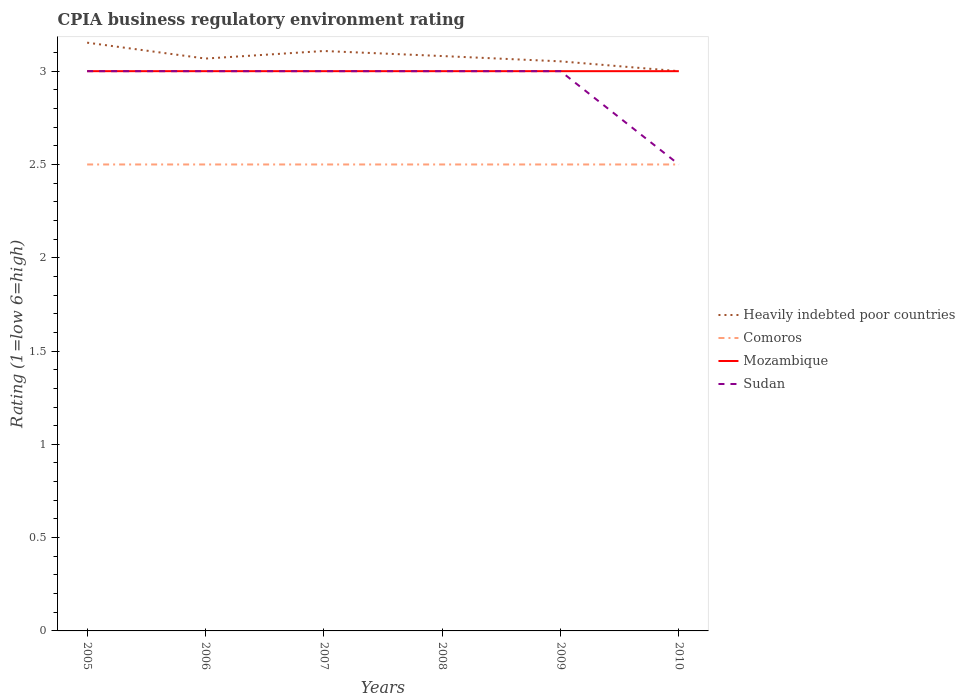How many different coloured lines are there?
Your response must be concise. 4. Is the number of lines equal to the number of legend labels?
Give a very brief answer. Yes. Across all years, what is the maximum CPIA rating in Heavily indebted poor countries?
Offer a terse response. 3. What is the difference between the highest and the second highest CPIA rating in Comoros?
Offer a terse response. 0. What is the difference between the highest and the lowest CPIA rating in Sudan?
Provide a short and direct response. 5. How many lines are there?
Make the answer very short. 4. What is the difference between two consecutive major ticks on the Y-axis?
Your answer should be very brief. 0.5. Does the graph contain grids?
Your answer should be very brief. No. How are the legend labels stacked?
Your answer should be compact. Vertical. What is the title of the graph?
Offer a very short reply. CPIA business regulatory environment rating. Does "Sudan" appear as one of the legend labels in the graph?
Keep it short and to the point. Yes. What is the label or title of the Y-axis?
Your answer should be very brief. Rating (1=low 6=high). What is the Rating (1=low 6=high) in Heavily indebted poor countries in 2005?
Provide a short and direct response. 3.15. What is the Rating (1=low 6=high) in Comoros in 2005?
Provide a short and direct response. 2.5. What is the Rating (1=low 6=high) in Mozambique in 2005?
Keep it short and to the point. 3. What is the Rating (1=low 6=high) of Sudan in 2005?
Keep it short and to the point. 3. What is the Rating (1=low 6=high) of Heavily indebted poor countries in 2006?
Provide a succinct answer. 3.07. What is the Rating (1=low 6=high) of Comoros in 2006?
Offer a very short reply. 2.5. What is the Rating (1=low 6=high) of Sudan in 2006?
Make the answer very short. 3. What is the Rating (1=low 6=high) in Heavily indebted poor countries in 2007?
Give a very brief answer. 3.11. What is the Rating (1=low 6=high) in Comoros in 2007?
Your response must be concise. 2.5. What is the Rating (1=low 6=high) in Heavily indebted poor countries in 2008?
Offer a very short reply. 3.08. What is the Rating (1=low 6=high) of Mozambique in 2008?
Your response must be concise. 3. What is the Rating (1=low 6=high) of Sudan in 2008?
Your response must be concise. 3. What is the Rating (1=low 6=high) in Heavily indebted poor countries in 2009?
Provide a succinct answer. 3.05. What is the Rating (1=low 6=high) in Heavily indebted poor countries in 2010?
Provide a short and direct response. 3. What is the Rating (1=low 6=high) in Sudan in 2010?
Ensure brevity in your answer.  2.5. Across all years, what is the maximum Rating (1=low 6=high) of Heavily indebted poor countries?
Ensure brevity in your answer.  3.15. Across all years, what is the maximum Rating (1=low 6=high) in Comoros?
Offer a terse response. 2.5. Across all years, what is the maximum Rating (1=low 6=high) of Mozambique?
Provide a short and direct response. 3. Across all years, what is the minimum Rating (1=low 6=high) of Heavily indebted poor countries?
Provide a succinct answer. 3. Across all years, what is the minimum Rating (1=low 6=high) of Mozambique?
Provide a succinct answer. 3. Across all years, what is the minimum Rating (1=low 6=high) of Sudan?
Your answer should be compact. 2.5. What is the total Rating (1=low 6=high) in Heavily indebted poor countries in the graph?
Make the answer very short. 18.46. What is the total Rating (1=low 6=high) of Mozambique in the graph?
Ensure brevity in your answer.  18. What is the difference between the Rating (1=low 6=high) in Heavily indebted poor countries in 2005 and that in 2006?
Provide a short and direct response. 0.09. What is the difference between the Rating (1=low 6=high) in Heavily indebted poor countries in 2005 and that in 2007?
Offer a very short reply. 0.04. What is the difference between the Rating (1=low 6=high) of Heavily indebted poor countries in 2005 and that in 2008?
Your answer should be compact. 0.07. What is the difference between the Rating (1=low 6=high) in Comoros in 2005 and that in 2008?
Your response must be concise. 0. What is the difference between the Rating (1=low 6=high) in Mozambique in 2005 and that in 2008?
Your answer should be very brief. 0. What is the difference between the Rating (1=low 6=high) in Sudan in 2005 and that in 2008?
Offer a terse response. 0. What is the difference between the Rating (1=low 6=high) in Heavily indebted poor countries in 2005 and that in 2009?
Provide a succinct answer. 0.1. What is the difference between the Rating (1=low 6=high) in Comoros in 2005 and that in 2009?
Offer a terse response. 0. What is the difference between the Rating (1=low 6=high) of Heavily indebted poor countries in 2005 and that in 2010?
Give a very brief answer. 0.15. What is the difference between the Rating (1=low 6=high) of Heavily indebted poor countries in 2006 and that in 2007?
Your answer should be compact. -0.04. What is the difference between the Rating (1=low 6=high) in Comoros in 2006 and that in 2007?
Provide a succinct answer. 0. What is the difference between the Rating (1=low 6=high) of Mozambique in 2006 and that in 2007?
Provide a short and direct response. 0. What is the difference between the Rating (1=low 6=high) of Sudan in 2006 and that in 2007?
Provide a succinct answer. 0. What is the difference between the Rating (1=low 6=high) in Heavily indebted poor countries in 2006 and that in 2008?
Give a very brief answer. -0.01. What is the difference between the Rating (1=low 6=high) of Comoros in 2006 and that in 2008?
Provide a succinct answer. 0. What is the difference between the Rating (1=low 6=high) in Heavily indebted poor countries in 2006 and that in 2009?
Give a very brief answer. 0.01. What is the difference between the Rating (1=low 6=high) of Comoros in 2006 and that in 2009?
Your answer should be compact. 0. What is the difference between the Rating (1=low 6=high) in Heavily indebted poor countries in 2006 and that in 2010?
Ensure brevity in your answer.  0.07. What is the difference between the Rating (1=low 6=high) of Comoros in 2006 and that in 2010?
Your answer should be very brief. 0. What is the difference between the Rating (1=low 6=high) in Heavily indebted poor countries in 2007 and that in 2008?
Ensure brevity in your answer.  0.03. What is the difference between the Rating (1=low 6=high) in Sudan in 2007 and that in 2008?
Offer a very short reply. 0. What is the difference between the Rating (1=low 6=high) in Heavily indebted poor countries in 2007 and that in 2009?
Keep it short and to the point. 0.06. What is the difference between the Rating (1=low 6=high) of Mozambique in 2007 and that in 2009?
Your answer should be compact. 0. What is the difference between the Rating (1=low 6=high) in Sudan in 2007 and that in 2009?
Make the answer very short. 0. What is the difference between the Rating (1=low 6=high) of Heavily indebted poor countries in 2007 and that in 2010?
Provide a succinct answer. 0.11. What is the difference between the Rating (1=low 6=high) in Mozambique in 2007 and that in 2010?
Your answer should be very brief. 0. What is the difference between the Rating (1=low 6=high) of Sudan in 2007 and that in 2010?
Provide a short and direct response. 0.5. What is the difference between the Rating (1=low 6=high) of Heavily indebted poor countries in 2008 and that in 2009?
Provide a succinct answer. 0.03. What is the difference between the Rating (1=low 6=high) of Heavily indebted poor countries in 2008 and that in 2010?
Ensure brevity in your answer.  0.08. What is the difference between the Rating (1=low 6=high) of Comoros in 2008 and that in 2010?
Keep it short and to the point. 0. What is the difference between the Rating (1=low 6=high) of Mozambique in 2008 and that in 2010?
Make the answer very short. 0. What is the difference between the Rating (1=low 6=high) in Heavily indebted poor countries in 2009 and that in 2010?
Offer a very short reply. 0.05. What is the difference between the Rating (1=low 6=high) in Comoros in 2009 and that in 2010?
Offer a very short reply. 0. What is the difference between the Rating (1=low 6=high) in Sudan in 2009 and that in 2010?
Your answer should be very brief. 0.5. What is the difference between the Rating (1=low 6=high) of Heavily indebted poor countries in 2005 and the Rating (1=low 6=high) of Comoros in 2006?
Offer a very short reply. 0.65. What is the difference between the Rating (1=low 6=high) of Heavily indebted poor countries in 2005 and the Rating (1=low 6=high) of Mozambique in 2006?
Give a very brief answer. 0.15. What is the difference between the Rating (1=low 6=high) in Heavily indebted poor countries in 2005 and the Rating (1=low 6=high) in Sudan in 2006?
Your response must be concise. 0.15. What is the difference between the Rating (1=low 6=high) in Comoros in 2005 and the Rating (1=low 6=high) in Sudan in 2006?
Make the answer very short. -0.5. What is the difference between the Rating (1=low 6=high) in Mozambique in 2005 and the Rating (1=low 6=high) in Sudan in 2006?
Ensure brevity in your answer.  0. What is the difference between the Rating (1=low 6=high) in Heavily indebted poor countries in 2005 and the Rating (1=low 6=high) in Comoros in 2007?
Ensure brevity in your answer.  0.65. What is the difference between the Rating (1=low 6=high) of Heavily indebted poor countries in 2005 and the Rating (1=low 6=high) of Mozambique in 2007?
Your answer should be compact. 0.15. What is the difference between the Rating (1=low 6=high) in Heavily indebted poor countries in 2005 and the Rating (1=low 6=high) in Sudan in 2007?
Give a very brief answer. 0.15. What is the difference between the Rating (1=low 6=high) in Comoros in 2005 and the Rating (1=low 6=high) in Sudan in 2007?
Your answer should be very brief. -0.5. What is the difference between the Rating (1=low 6=high) of Mozambique in 2005 and the Rating (1=low 6=high) of Sudan in 2007?
Your answer should be very brief. 0. What is the difference between the Rating (1=low 6=high) in Heavily indebted poor countries in 2005 and the Rating (1=low 6=high) in Comoros in 2008?
Your response must be concise. 0.65. What is the difference between the Rating (1=low 6=high) of Heavily indebted poor countries in 2005 and the Rating (1=low 6=high) of Mozambique in 2008?
Your response must be concise. 0.15. What is the difference between the Rating (1=low 6=high) in Heavily indebted poor countries in 2005 and the Rating (1=low 6=high) in Sudan in 2008?
Your answer should be compact. 0.15. What is the difference between the Rating (1=low 6=high) of Comoros in 2005 and the Rating (1=low 6=high) of Mozambique in 2008?
Ensure brevity in your answer.  -0.5. What is the difference between the Rating (1=low 6=high) in Mozambique in 2005 and the Rating (1=low 6=high) in Sudan in 2008?
Offer a terse response. 0. What is the difference between the Rating (1=low 6=high) of Heavily indebted poor countries in 2005 and the Rating (1=low 6=high) of Comoros in 2009?
Give a very brief answer. 0.65. What is the difference between the Rating (1=low 6=high) in Heavily indebted poor countries in 2005 and the Rating (1=low 6=high) in Mozambique in 2009?
Provide a short and direct response. 0.15. What is the difference between the Rating (1=low 6=high) in Heavily indebted poor countries in 2005 and the Rating (1=low 6=high) in Sudan in 2009?
Keep it short and to the point. 0.15. What is the difference between the Rating (1=low 6=high) in Comoros in 2005 and the Rating (1=low 6=high) in Sudan in 2009?
Provide a succinct answer. -0.5. What is the difference between the Rating (1=low 6=high) of Mozambique in 2005 and the Rating (1=low 6=high) of Sudan in 2009?
Your response must be concise. 0. What is the difference between the Rating (1=low 6=high) in Heavily indebted poor countries in 2005 and the Rating (1=low 6=high) in Comoros in 2010?
Make the answer very short. 0.65. What is the difference between the Rating (1=low 6=high) of Heavily indebted poor countries in 2005 and the Rating (1=low 6=high) of Mozambique in 2010?
Provide a succinct answer. 0.15. What is the difference between the Rating (1=low 6=high) of Heavily indebted poor countries in 2005 and the Rating (1=low 6=high) of Sudan in 2010?
Provide a succinct answer. 0.65. What is the difference between the Rating (1=low 6=high) in Heavily indebted poor countries in 2006 and the Rating (1=low 6=high) in Comoros in 2007?
Your answer should be compact. 0.57. What is the difference between the Rating (1=low 6=high) in Heavily indebted poor countries in 2006 and the Rating (1=low 6=high) in Mozambique in 2007?
Offer a very short reply. 0.07. What is the difference between the Rating (1=low 6=high) of Heavily indebted poor countries in 2006 and the Rating (1=low 6=high) of Sudan in 2007?
Your answer should be compact. 0.07. What is the difference between the Rating (1=low 6=high) in Comoros in 2006 and the Rating (1=low 6=high) in Mozambique in 2007?
Provide a short and direct response. -0.5. What is the difference between the Rating (1=low 6=high) in Heavily indebted poor countries in 2006 and the Rating (1=low 6=high) in Comoros in 2008?
Your answer should be very brief. 0.57. What is the difference between the Rating (1=low 6=high) in Heavily indebted poor countries in 2006 and the Rating (1=low 6=high) in Mozambique in 2008?
Offer a terse response. 0.07. What is the difference between the Rating (1=low 6=high) of Heavily indebted poor countries in 2006 and the Rating (1=low 6=high) of Sudan in 2008?
Your answer should be very brief. 0.07. What is the difference between the Rating (1=low 6=high) of Comoros in 2006 and the Rating (1=low 6=high) of Mozambique in 2008?
Keep it short and to the point. -0.5. What is the difference between the Rating (1=low 6=high) of Comoros in 2006 and the Rating (1=low 6=high) of Sudan in 2008?
Your answer should be very brief. -0.5. What is the difference between the Rating (1=low 6=high) in Mozambique in 2006 and the Rating (1=low 6=high) in Sudan in 2008?
Your answer should be compact. 0. What is the difference between the Rating (1=low 6=high) of Heavily indebted poor countries in 2006 and the Rating (1=low 6=high) of Comoros in 2009?
Ensure brevity in your answer.  0.57. What is the difference between the Rating (1=low 6=high) in Heavily indebted poor countries in 2006 and the Rating (1=low 6=high) in Mozambique in 2009?
Make the answer very short. 0.07. What is the difference between the Rating (1=low 6=high) of Heavily indebted poor countries in 2006 and the Rating (1=low 6=high) of Sudan in 2009?
Your answer should be compact. 0.07. What is the difference between the Rating (1=low 6=high) in Mozambique in 2006 and the Rating (1=low 6=high) in Sudan in 2009?
Offer a very short reply. 0. What is the difference between the Rating (1=low 6=high) in Heavily indebted poor countries in 2006 and the Rating (1=low 6=high) in Comoros in 2010?
Provide a short and direct response. 0.57. What is the difference between the Rating (1=low 6=high) of Heavily indebted poor countries in 2006 and the Rating (1=low 6=high) of Mozambique in 2010?
Your answer should be compact. 0.07. What is the difference between the Rating (1=low 6=high) in Heavily indebted poor countries in 2006 and the Rating (1=low 6=high) in Sudan in 2010?
Provide a short and direct response. 0.57. What is the difference between the Rating (1=low 6=high) of Comoros in 2006 and the Rating (1=low 6=high) of Mozambique in 2010?
Offer a very short reply. -0.5. What is the difference between the Rating (1=low 6=high) of Comoros in 2006 and the Rating (1=low 6=high) of Sudan in 2010?
Keep it short and to the point. 0. What is the difference between the Rating (1=low 6=high) of Heavily indebted poor countries in 2007 and the Rating (1=low 6=high) of Comoros in 2008?
Your answer should be very brief. 0.61. What is the difference between the Rating (1=low 6=high) in Heavily indebted poor countries in 2007 and the Rating (1=low 6=high) in Mozambique in 2008?
Your response must be concise. 0.11. What is the difference between the Rating (1=low 6=high) in Heavily indebted poor countries in 2007 and the Rating (1=low 6=high) in Sudan in 2008?
Ensure brevity in your answer.  0.11. What is the difference between the Rating (1=low 6=high) in Comoros in 2007 and the Rating (1=low 6=high) in Sudan in 2008?
Give a very brief answer. -0.5. What is the difference between the Rating (1=low 6=high) of Mozambique in 2007 and the Rating (1=low 6=high) of Sudan in 2008?
Provide a succinct answer. 0. What is the difference between the Rating (1=low 6=high) in Heavily indebted poor countries in 2007 and the Rating (1=low 6=high) in Comoros in 2009?
Your response must be concise. 0.61. What is the difference between the Rating (1=low 6=high) in Heavily indebted poor countries in 2007 and the Rating (1=low 6=high) in Mozambique in 2009?
Make the answer very short. 0.11. What is the difference between the Rating (1=low 6=high) of Heavily indebted poor countries in 2007 and the Rating (1=low 6=high) of Sudan in 2009?
Give a very brief answer. 0.11. What is the difference between the Rating (1=low 6=high) in Comoros in 2007 and the Rating (1=low 6=high) in Sudan in 2009?
Keep it short and to the point. -0.5. What is the difference between the Rating (1=low 6=high) in Mozambique in 2007 and the Rating (1=low 6=high) in Sudan in 2009?
Your response must be concise. 0. What is the difference between the Rating (1=low 6=high) of Heavily indebted poor countries in 2007 and the Rating (1=low 6=high) of Comoros in 2010?
Give a very brief answer. 0.61. What is the difference between the Rating (1=low 6=high) of Heavily indebted poor countries in 2007 and the Rating (1=low 6=high) of Mozambique in 2010?
Ensure brevity in your answer.  0.11. What is the difference between the Rating (1=low 6=high) in Heavily indebted poor countries in 2007 and the Rating (1=low 6=high) in Sudan in 2010?
Provide a succinct answer. 0.61. What is the difference between the Rating (1=low 6=high) in Comoros in 2007 and the Rating (1=low 6=high) in Sudan in 2010?
Keep it short and to the point. 0. What is the difference between the Rating (1=low 6=high) of Heavily indebted poor countries in 2008 and the Rating (1=low 6=high) of Comoros in 2009?
Provide a short and direct response. 0.58. What is the difference between the Rating (1=low 6=high) in Heavily indebted poor countries in 2008 and the Rating (1=low 6=high) in Mozambique in 2009?
Make the answer very short. 0.08. What is the difference between the Rating (1=low 6=high) in Heavily indebted poor countries in 2008 and the Rating (1=low 6=high) in Sudan in 2009?
Your response must be concise. 0.08. What is the difference between the Rating (1=low 6=high) in Comoros in 2008 and the Rating (1=low 6=high) in Mozambique in 2009?
Keep it short and to the point. -0.5. What is the difference between the Rating (1=low 6=high) in Mozambique in 2008 and the Rating (1=low 6=high) in Sudan in 2009?
Provide a short and direct response. 0. What is the difference between the Rating (1=low 6=high) in Heavily indebted poor countries in 2008 and the Rating (1=low 6=high) in Comoros in 2010?
Give a very brief answer. 0.58. What is the difference between the Rating (1=low 6=high) of Heavily indebted poor countries in 2008 and the Rating (1=low 6=high) of Mozambique in 2010?
Your answer should be compact. 0.08. What is the difference between the Rating (1=low 6=high) of Heavily indebted poor countries in 2008 and the Rating (1=low 6=high) of Sudan in 2010?
Offer a terse response. 0.58. What is the difference between the Rating (1=low 6=high) of Comoros in 2008 and the Rating (1=low 6=high) of Sudan in 2010?
Give a very brief answer. 0. What is the difference between the Rating (1=low 6=high) in Heavily indebted poor countries in 2009 and the Rating (1=low 6=high) in Comoros in 2010?
Offer a very short reply. 0.55. What is the difference between the Rating (1=low 6=high) in Heavily indebted poor countries in 2009 and the Rating (1=low 6=high) in Mozambique in 2010?
Provide a short and direct response. 0.05. What is the difference between the Rating (1=low 6=high) of Heavily indebted poor countries in 2009 and the Rating (1=low 6=high) of Sudan in 2010?
Provide a short and direct response. 0.55. What is the difference between the Rating (1=low 6=high) in Comoros in 2009 and the Rating (1=low 6=high) in Mozambique in 2010?
Make the answer very short. -0.5. What is the difference between the Rating (1=low 6=high) in Comoros in 2009 and the Rating (1=low 6=high) in Sudan in 2010?
Your answer should be very brief. 0. What is the average Rating (1=low 6=high) in Heavily indebted poor countries per year?
Give a very brief answer. 3.08. What is the average Rating (1=low 6=high) in Mozambique per year?
Your answer should be very brief. 3. What is the average Rating (1=low 6=high) of Sudan per year?
Offer a terse response. 2.92. In the year 2005, what is the difference between the Rating (1=low 6=high) of Heavily indebted poor countries and Rating (1=low 6=high) of Comoros?
Offer a terse response. 0.65. In the year 2005, what is the difference between the Rating (1=low 6=high) of Heavily indebted poor countries and Rating (1=low 6=high) of Mozambique?
Give a very brief answer. 0.15. In the year 2005, what is the difference between the Rating (1=low 6=high) of Heavily indebted poor countries and Rating (1=low 6=high) of Sudan?
Offer a very short reply. 0.15. In the year 2005, what is the difference between the Rating (1=low 6=high) in Comoros and Rating (1=low 6=high) in Sudan?
Provide a short and direct response. -0.5. In the year 2006, what is the difference between the Rating (1=low 6=high) in Heavily indebted poor countries and Rating (1=low 6=high) in Comoros?
Offer a terse response. 0.57. In the year 2006, what is the difference between the Rating (1=low 6=high) of Heavily indebted poor countries and Rating (1=low 6=high) of Mozambique?
Offer a very short reply. 0.07. In the year 2006, what is the difference between the Rating (1=low 6=high) of Heavily indebted poor countries and Rating (1=low 6=high) of Sudan?
Give a very brief answer. 0.07. In the year 2006, what is the difference between the Rating (1=low 6=high) of Comoros and Rating (1=low 6=high) of Mozambique?
Give a very brief answer. -0.5. In the year 2006, what is the difference between the Rating (1=low 6=high) in Comoros and Rating (1=low 6=high) in Sudan?
Your response must be concise. -0.5. In the year 2007, what is the difference between the Rating (1=low 6=high) of Heavily indebted poor countries and Rating (1=low 6=high) of Comoros?
Your answer should be very brief. 0.61. In the year 2007, what is the difference between the Rating (1=low 6=high) in Heavily indebted poor countries and Rating (1=low 6=high) in Mozambique?
Provide a short and direct response. 0.11. In the year 2007, what is the difference between the Rating (1=low 6=high) of Heavily indebted poor countries and Rating (1=low 6=high) of Sudan?
Your response must be concise. 0.11. In the year 2007, what is the difference between the Rating (1=low 6=high) of Comoros and Rating (1=low 6=high) of Mozambique?
Give a very brief answer. -0.5. In the year 2007, what is the difference between the Rating (1=low 6=high) of Comoros and Rating (1=low 6=high) of Sudan?
Make the answer very short. -0.5. In the year 2008, what is the difference between the Rating (1=low 6=high) of Heavily indebted poor countries and Rating (1=low 6=high) of Comoros?
Provide a succinct answer. 0.58. In the year 2008, what is the difference between the Rating (1=low 6=high) in Heavily indebted poor countries and Rating (1=low 6=high) in Mozambique?
Make the answer very short. 0.08. In the year 2008, what is the difference between the Rating (1=low 6=high) of Heavily indebted poor countries and Rating (1=low 6=high) of Sudan?
Provide a succinct answer. 0.08. In the year 2008, what is the difference between the Rating (1=low 6=high) in Comoros and Rating (1=low 6=high) in Mozambique?
Ensure brevity in your answer.  -0.5. In the year 2008, what is the difference between the Rating (1=low 6=high) in Comoros and Rating (1=low 6=high) in Sudan?
Give a very brief answer. -0.5. In the year 2008, what is the difference between the Rating (1=low 6=high) of Mozambique and Rating (1=low 6=high) of Sudan?
Provide a succinct answer. 0. In the year 2009, what is the difference between the Rating (1=low 6=high) in Heavily indebted poor countries and Rating (1=low 6=high) in Comoros?
Provide a succinct answer. 0.55. In the year 2009, what is the difference between the Rating (1=low 6=high) in Heavily indebted poor countries and Rating (1=low 6=high) in Mozambique?
Your answer should be very brief. 0.05. In the year 2009, what is the difference between the Rating (1=low 6=high) of Heavily indebted poor countries and Rating (1=low 6=high) of Sudan?
Your answer should be compact. 0.05. In the year 2009, what is the difference between the Rating (1=low 6=high) of Comoros and Rating (1=low 6=high) of Mozambique?
Provide a short and direct response. -0.5. In the year 2009, what is the difference between the Rating (1=low 6=high) in Comoros and Rating (1=low 6=high) in Sudan?
Keep it short and to the point. -0.5. In the year 2010, what is the difference between the Rating (1=low 6=high) of Heavily indebted poor countries and Rating (1=low 6=high) of Comoros?
Ensure brevity in your answer.  0.5. In the year 2010, what is the difference between the Rating (1=low 6=high) of Comoros and Rating (1=low 6=high) of Sudan?
Provide a succinct answer. 0. In the year 2010, what is the difference between the Rating (1=low 6=high) in Mozambique and Rating (1=low 6=high) in Sudan?
Offer a very short reply. 0.5. What is the ratio of the Rating (1=low 6=high) in Heavily indebted poor countries in 2005 to that in 2006?
Offer a terse response. 1.03. What is the ratio of the Rating (1=low 6=high) in Comoros in 2005 to that in 2006?
Ensure brevity in your answer.  1. What is the ratio of the Rating (1=low 6=high) in Mozambique in 2005 to that in 2006?
Your answer should be compact. 1. What is the ratio of the Rating (1=low 6=high) of Heavily indebted poor countries in 2005 to that in 2007?
Your response must be concise. 1.01. What is the ratio of the Rating (1=low 6=high) of Sudan in 2005 to that in 2007?
Make the answer very short. 1. What is the ratio of the Rating (1=low 6=high) in Heavily indebted poor countries in 2005 to that in 2008?
Provide a succinct answer. 1.02. What is the ratio of the Rating (1=low 6=high) of Comoros in 2005 to that in 2008?
Ensure brevity in your answer.  1. What is the ratio of the Rating (1=low 6=high) of Sudan in 2005 to that in 2008?
Offer a very short reply. 1. What is the ratio of the Rating (1=low 6=high) in Heavily indebted poor countries in 2005 to that in 2009?
Offer a very short reply. 1.03. What is the ratio of the Rating (1=low 6=high) in Mozambique in 2005 to that in 2009?
Your response must be concise. 1. What is the ratio of the Rating (1=low 6=high) of Heavily indebted poor countries in 2005 to that in 2010?
Provide a short and direct response. 1.05. What is the ratio of the Rating (1=low 6=high) in Comoros in 2005 to that in 2010?
Offer a very short reply. 1. What is the ratio of the Rating (1=low 6=high) of Mozambique in 2005 to that in 2010?
Your answer should be very brief. 1. What is the ratio of the Rating (1=low 6=high) of Sudan in 2005 to that in 2010?
Keep it short and to the point. 1.2. What is the ratio of the Rating (1=low 6=high) of Comoros in 2006 to that in 2007?
Your answer should be compact. 1. What is the ratio of the Rating (1=low 6=high) in Mozambique in 2006 to that in 2007?
Ensure brevity in your answer.  1. What is the ratio of the Rating (1=low 6=high) of Heavily indebted poor countries in 2006 to that in 2008?
Keep it short and to the point. 1. What is the ratio of the Rating (1=low 6=high) in Mozambique in 2006 to that in 2008?
Provide a succinct answer. 1. What is the ratio of the Rating (1=low 6=high) of Comoros in 2006 to that in 2009?
Give a very brief answer. 1. What is the ratio of the Rating (1=low 6=high) in Heavily indebted poor countries in 2006 to that in 2010?
Your response must be concise. 1.02. What is the ratio of the Rating (1=low 6=high) of Comoros in 2006 to that in 2010?
Ensure brevity in your answer.  1. What is the ratio of the Rating (1=low 6=high) in Mozambique in 2006 to that in 2010?
Keep it short and to the point. 1. What is the ratio of the Rating (1=low 6=high) in Sudan in 2006 to that in 2010?
Your answer should be compact. 1.2. What is the ratio of the Rating (1=low 6=high) of Heavily indebted poor countries in 2007 to that in 2008?
Provide a short and direct response. 1.01. What is the ratio of the Rating (1=low 6=high) in Sudan in 2007 to that in 2008?
Provide a short and direct response. 1. What is the ratio of the Rating (1=low 6=high) in Heavily indebted poor countries in 2007 to that in 2009?
Your answer should be compact. 1.02. What is the ratio of the Rating (1=low 6=high) of Comoros in 2007 to that in 2009?
Your response must be concise. 1. What is the ratio of the Rating (1=low 6=high) in Mozambique in 2007 to that in 2009?
Give a very brief answer. 1. What is the ratio of the Rating (1=low 6=high) of Sudan in 2007 to that in 2009?
Offer a very short reply. 1. What is the ratio of the Rating (1=low 6=high) of Heavily indebted poor countries in 2007 to that in 2010?
Your response must be concise. 1.04. What is the ratio of the Rating (1=low 6=high) in Comoros in 2007 to that in 2010?
Ensure brevity in your answer.  1. What is the ratio of the Rating (1=low 6=high) of Sudan in 2007 to that in 2010?
Make the answer very short. 1.2. What is the ratio of the Rating (1=low 6=high) of Heavily indebted poor countries in 2008 to that in 2009?
Offer a very short reply. 1.01. What is the ratio of the Rating (1=low 6=high) in Comoros in 2008 to that in 2009?
Your response must be concise. 1. What is the ratio of the Rating (1=low 6=high) of Sudan in 2008 to that in 2009?
Provide a short and direct response. 1. What is the ratio of the Rating (1=low 6=high) in Comoros in 2008 to that in 2010?
Your answer should be very brief. 1. What is the ratio of the Rating (1=low 6=high) in Mozambique in 2008 to that in 2010?
Keep it short and to the point. 1. What is the ratio of the Rating (1=low 6=high) in Sudan in 2008 to that in 2010?
Provide a short and direct response. 1.2. What is the ratio of the Rating (1=low 6=high) in Heavily indebted poor countries in 2009 to that in 2010?
Your answer should be compact. 1.02. What is the ratio of the Rating (1=low 6=high) in Mozambique in 2009 to that in 2010?
Your answer should be very brief. 1. What is the ratio of the Rating (1=low 6=high) in Sudan in 2009 to that in 2010?
Offer a terse response. 1.2. What is the difference between the highest and the second highest Rating (1=low 6=high) of Heavily indebted poor countries?
Your answer should be very brief. 0.04. What is the difference between the highest and the lowest Rating (1=low 6=high) in Heavily indebted poor countries?
Ensure brevity in your answer.  0.15. What is the difference between the highest and the lowest Rating (1=low 6=high) of Comoros?
Offer a terse response. 0. 